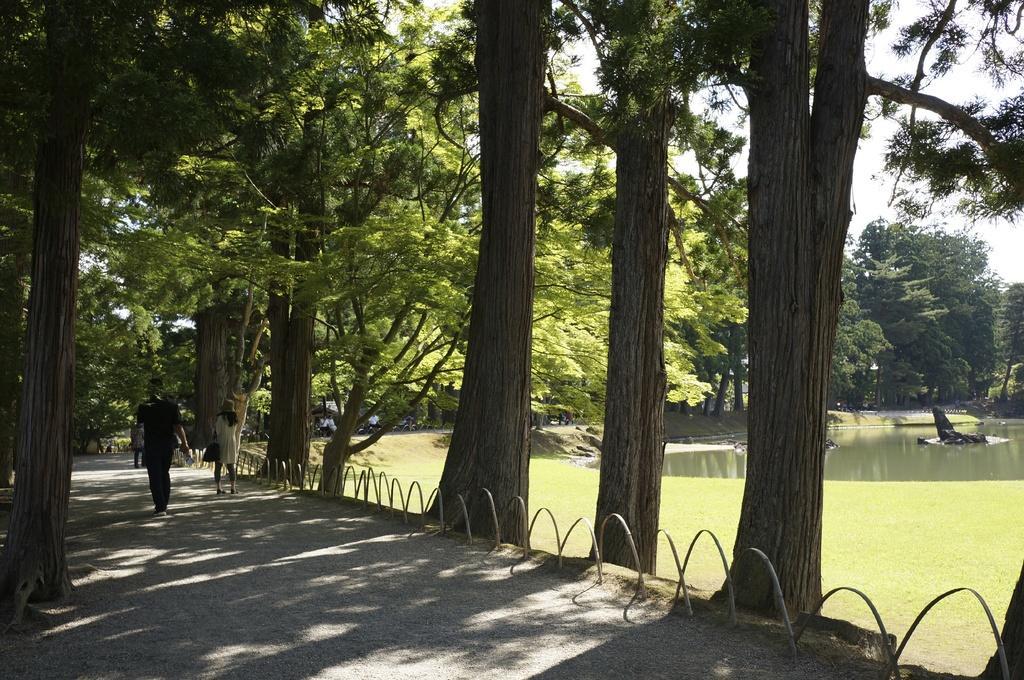How would you summarize this image in a sentence or two? At the top of the image there are some trees. At the bottom of the image few people are walking. Behind them there is water. 